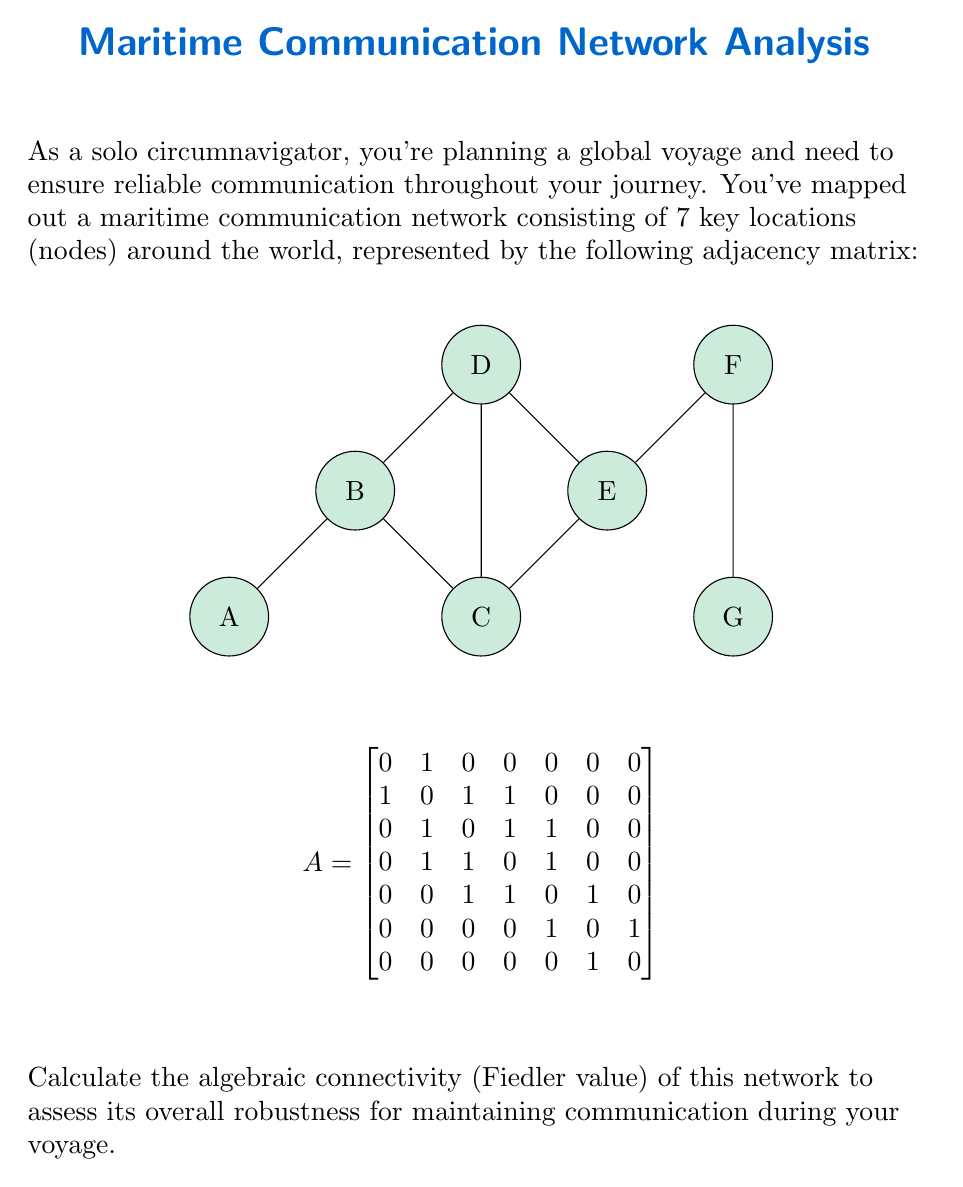Solve this math problem. To find the algebraic connectivity (Fiedler value) of the maritime communication network, we need to follow these steps:

1. Calculate the degree matrix $D$:
   $$D = \text{diag}(1, 3, 3, 3, 3, 2, 1)$$

2. Compute the Laplacian matrix $L = D - A$:
   $$L = \begin{bmatrix}
   1 & -1 & 0 & 0 & 0 & 0 & 0 \\
   -1 & 3 & -1 & -1 & 0 & 0 & 0 \\
   0 & -1 & 3 & -1 & -1 & 0 & 0 \\
   0 & -1 & -1 & 3 & -1 & 0 & 0 \\
   0 & 0 & -1 & -1 & 3 & -1 & 0 \\
   0 & 0 & 0 & 0 & -1 & 2 & -1 \\
   0 & 0 & 0 & 0 & 0 & -1 & 1
   \end{bmatrix}$$

3. Find the eigenvalues of $L$ using a computer algebra system or numerical methods. The eigenvalues are approximately:
   $$\lambda_1 \approx 0$$
   $$\lambda_2 \approx 0.3249$$
   $$\lambda_3 \approx 0.8038$$
   $$\lambda_4 \approx 1.6277$$
   $$\lambda_5 \approx 2.5858$$
   $$\lambda_6 \approx 3.5990$$
   $$\lambda_7 \approx 5.0588$$

4. The algebraic connectivity (Fiedler value) is the second smallest eigenvalue, which is $\lambda_2 \approx 0.3249$.

The Fiedler value provides information about the network's connectivity and robustness. A higher value indicates better connectivity and resilience to node/edge failures. In this case, the relatively low value of 0.3249 suggests that the network may be vulnerable to disruptions, particularly if certain key nodes or connections are lost during your voyage.
Answer: 0.3249 